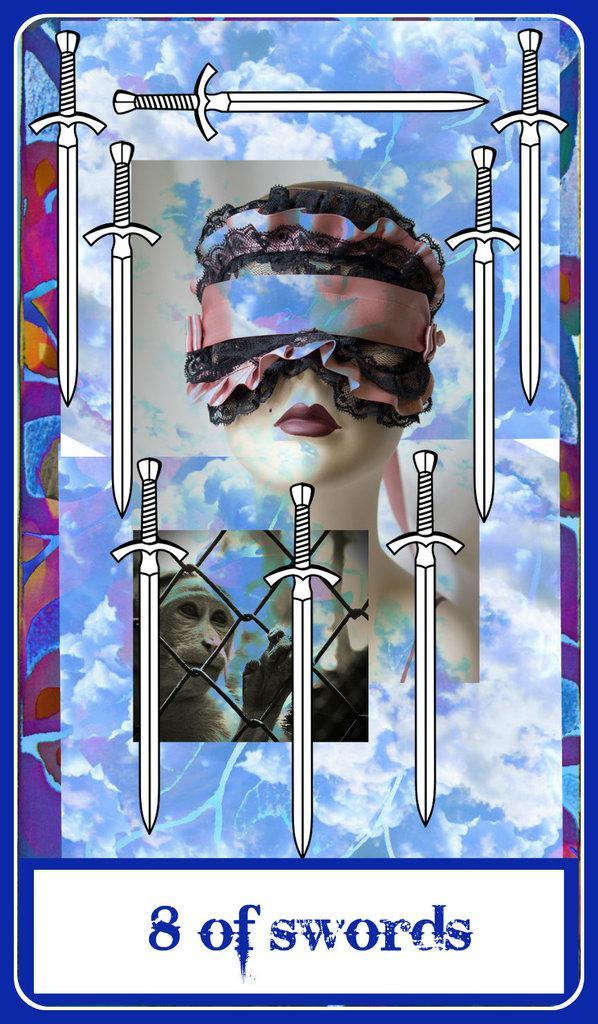How would you summarize this image in a sentence or two? In the image we can see there is a poster on which its written ¨8 of swords¨ and in the poster there is an image of a monkey standing behind the iron fencing and there is a statue of woman and there is a blindfold tied on the woman's eyes. There are swords image on the poster. 